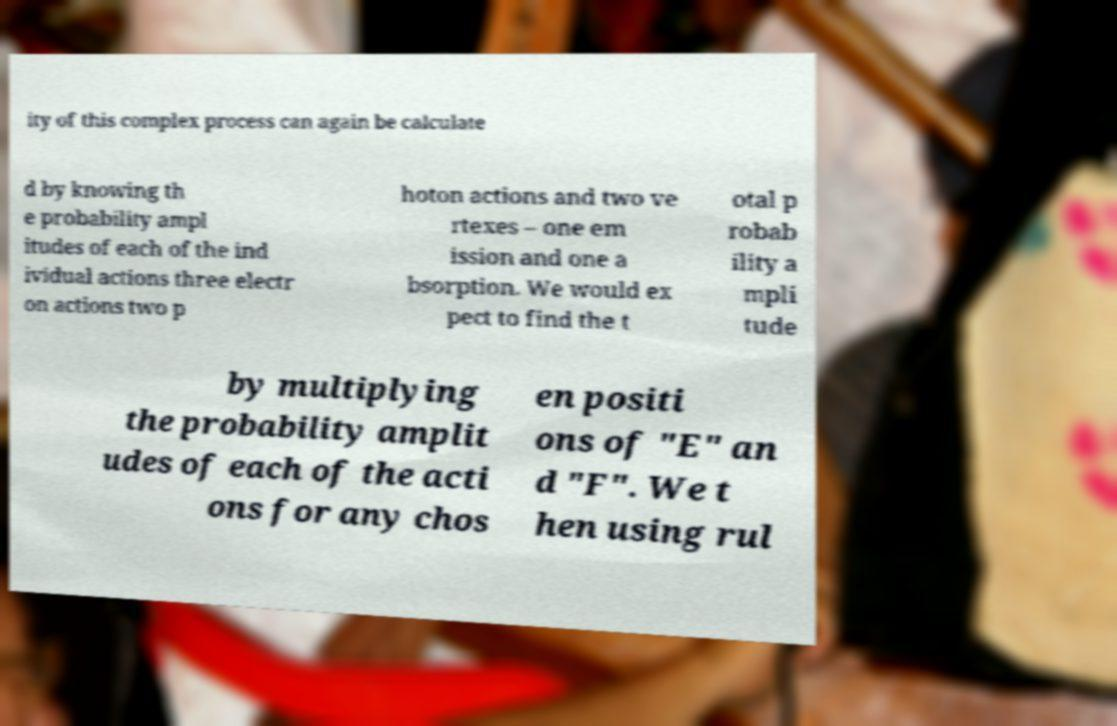Can you read and provide the text displayed in the image?This photo seems to have some interesting text. Can you extract and type it out for me? ity of this complex process can again be calculate d by knowing th e probability ampl itudes of each of the ind ividual actions three electr on actions two p hoton actions and two ve rtexes – one em ission and one a bsorption. We would ex pect to find the t otal p robab ility a mpli tude by multiplying the probability amplit udes of each of the acti ons for any chos en positi ons of "E" an d "F". We t hen using rul 